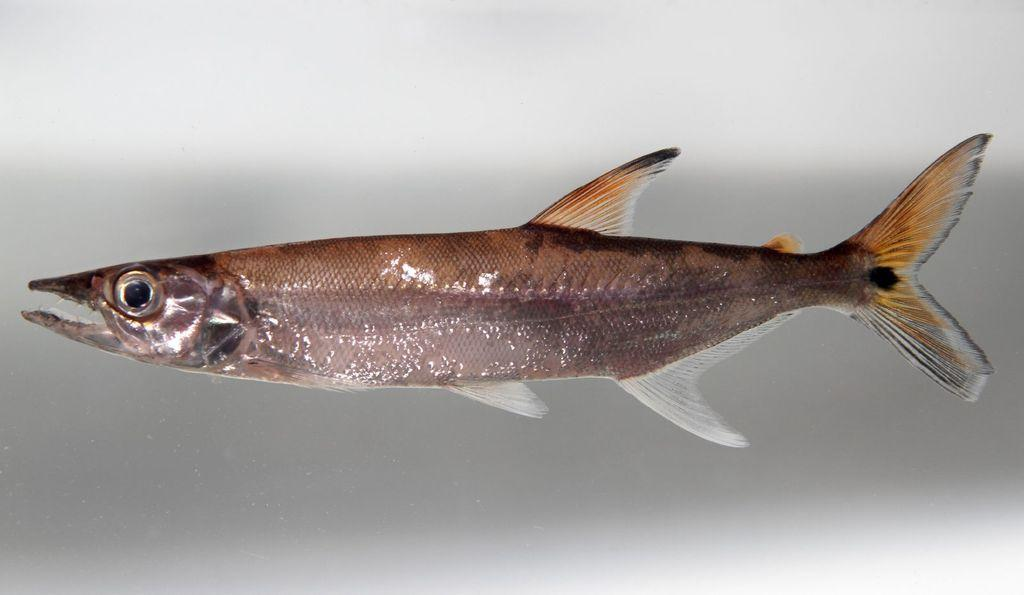What is the main subject of the image? There is a fish in the image. What color is the background of the image? The background of the image is white. What type of railway is visible in the image? There is no railway present in the image; it features a fish with a white background. What type of lettuce can be seen in the image? There is no lettuce present in the image; it features a fish with a white background. 